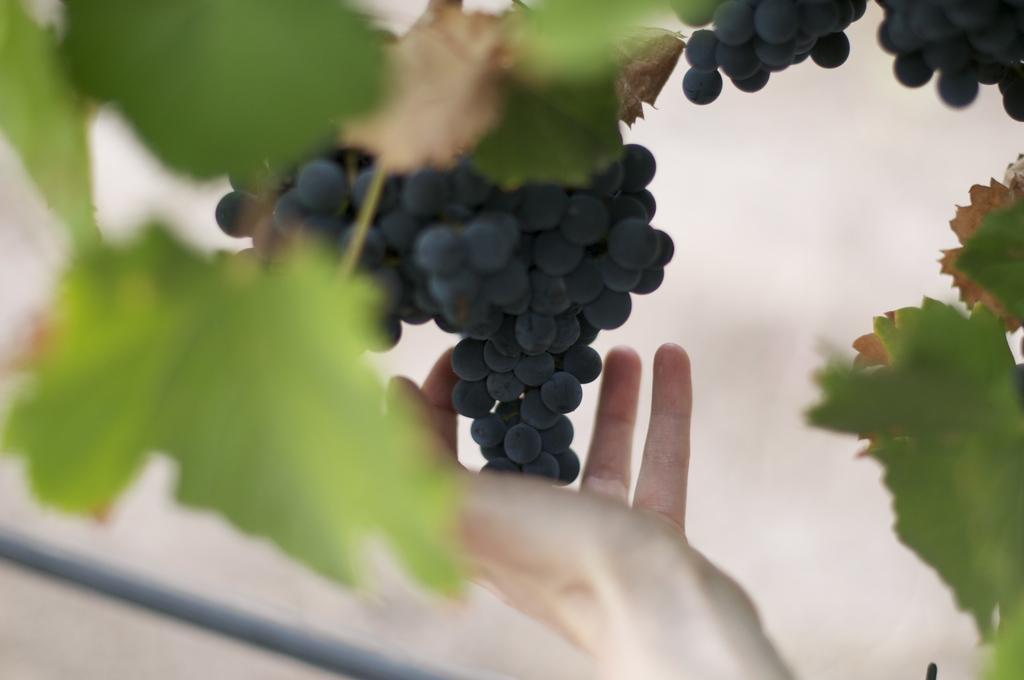Please provide a concise description of this image. In this image we can see bunch of grapes and a person's hand and leaves. 